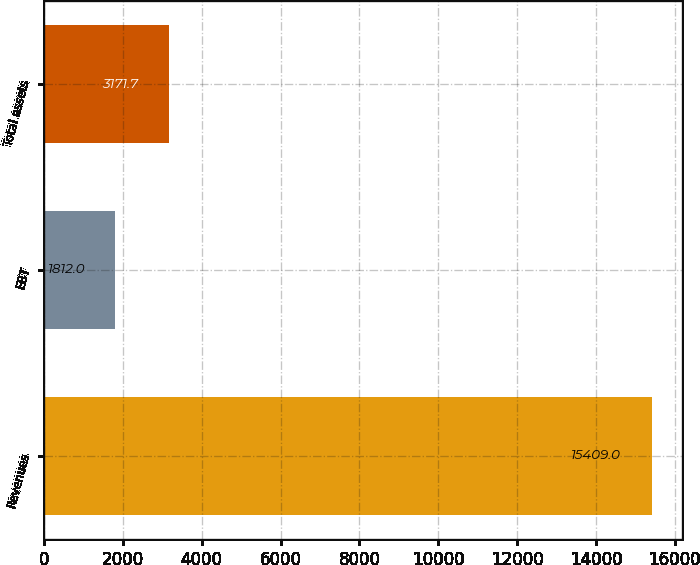<chart> <loc_0><loc_0><loc_500><loc_500><bar_chart><fcel>Revenues<fcel>EBT<fcel>Total assets<nl><fcel>15409<fcel>1812<fcel>3171.7<nl></chart> 